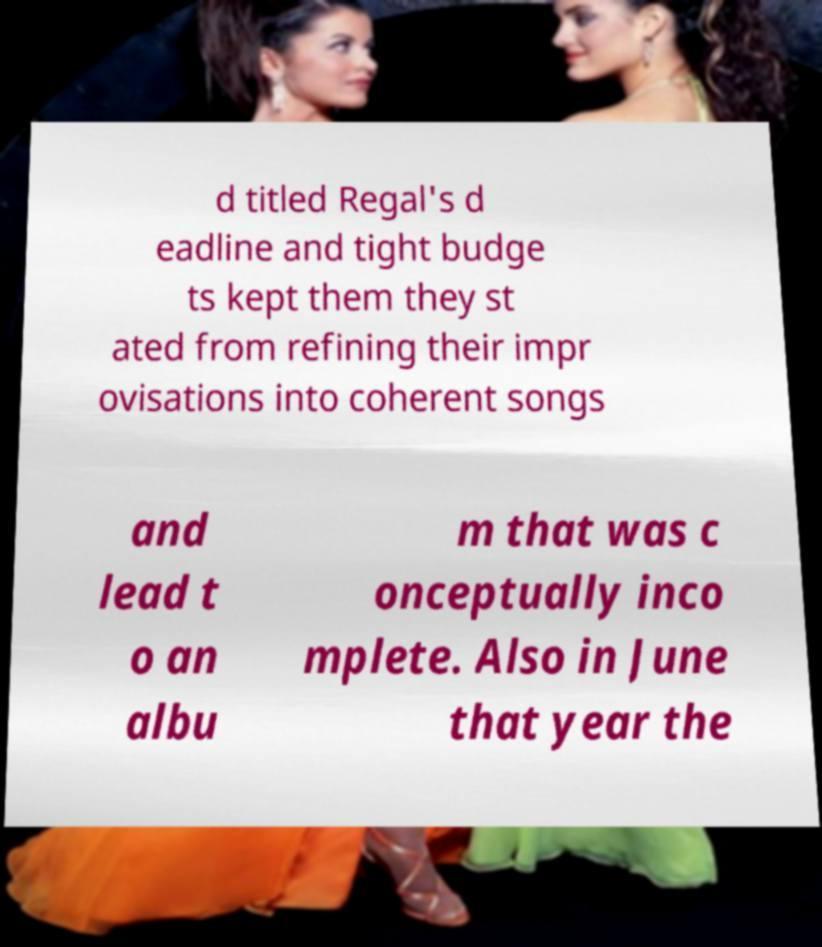What messages or text are displayed in this image? I need them in a readable, typed format. d titled Regal's d eadline and tight budge ts kept them they st ated from refining their impr ovisations into coherent songs and lead t o an albu m that was c onceptually inco mplete. Also in June that year the 